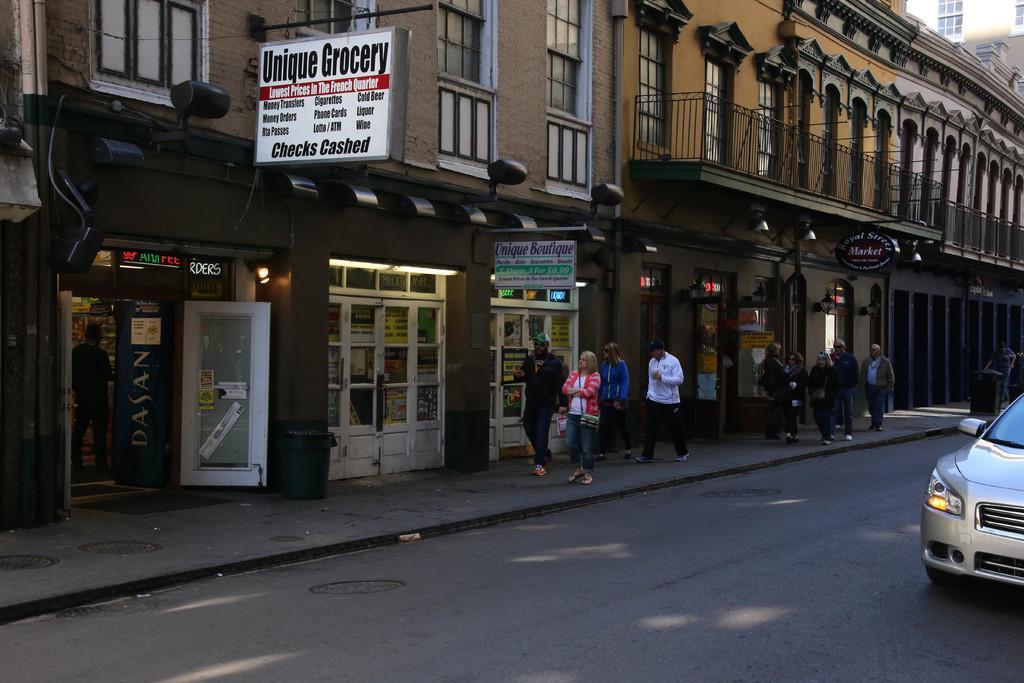Could you give a brief overview of what you see in this image? In this image in the center there are persons walking. On the right side there is a car. In the background there are buildings and there are boards with some text written on it. 